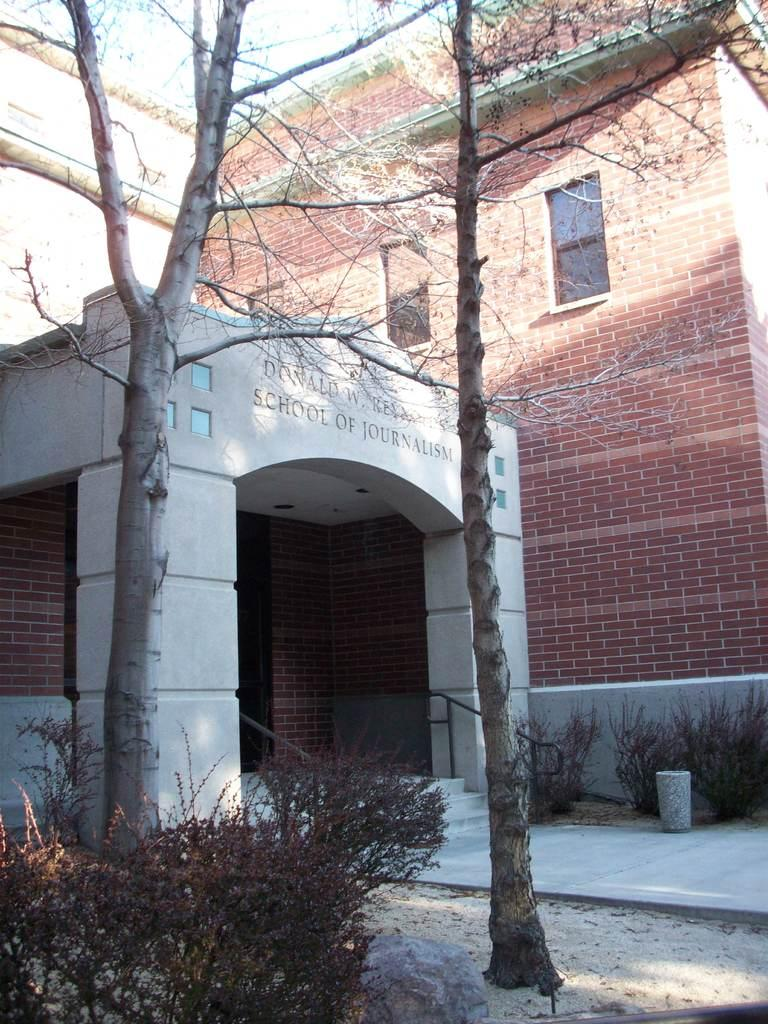What type of institution is depicted in the image? There is a journalism school in the image. What material is the school building made of? The school is made of bricks. What can be seen in front of the school? There are two trees and plants in front of the school. Can you see an apple in the pocket of a student in the image? There is no student or apple present in the image. 